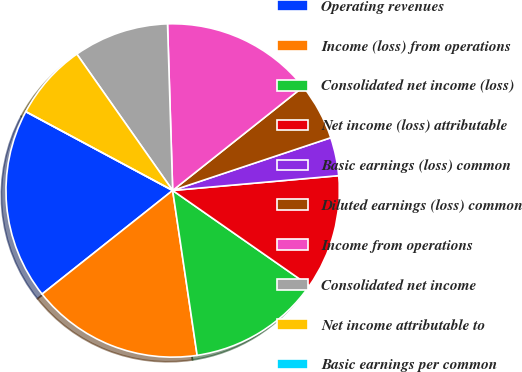Convert chart to OTSL. <chart><loc_0><loc_0><loc_500><loc_500><pie_chart><fcel>Operating revenues<fcel>Income (loss) from operations<fcel>Consolidated net income (loss)<fcel>Net income (loss) attributable<fcel>Basic earnings (loss) common<fcel>Diluted earnings (loss) common<fcel>Income from operations<fcel>Consolidated net income<fcel>Net income attributable to<fcel>Basic earnings per common<nl><fcel>18.52%<fcel>16.67%<fcel>12.96%<fcel>11.11%<fcel>3.71%<fcel>5.56%<fcel>14.81%<fcel>9.26%<fcel>7.41%<fcel>0.0%<nl></chart> 